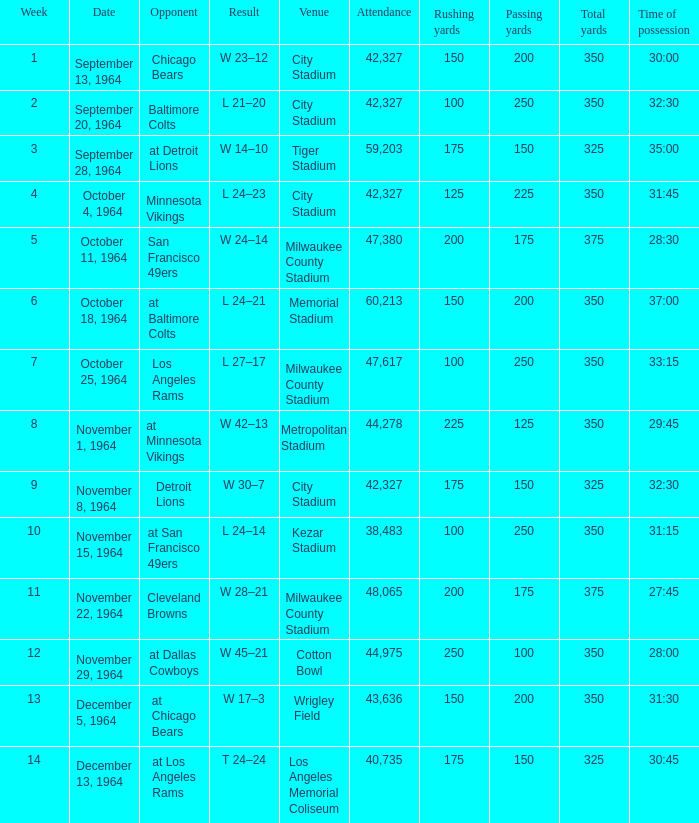What venue held that game with a result of l 24–14? Kezar Stadium. 